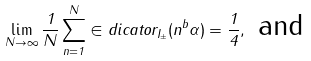Convert formula to latex. <formula><loc_0><loc_0><loc_500><loc_500>\lim _ { N \to \infty } \frac { 1 } { N } \sum _ { n = 1 } ^ { N } \in d i c a t o r _ { I _ { \pm } } ( n ^ { b } \alpha ) = \frac { 1 } { 4 } , \text { and}</formula> 